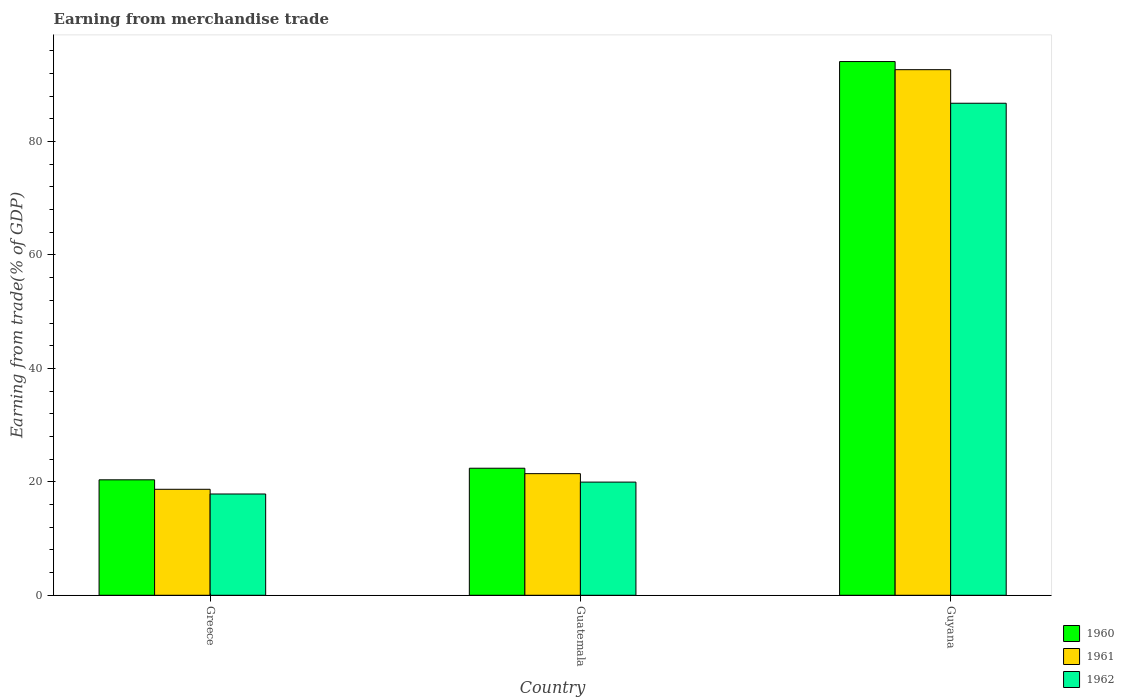Are the number of bars on each tick of the X-axis equal?
Offer a terse response. Yes. What is the label of the 2nd group of bars from the left?
Give a very brief answer. Guatemala. In how many cases, is the number of bars for a given country not equal to the number of legend labels?
Your answer should be compact. 0. What is the earnings from trade in 1961 in Greece?
Your answer should be compact. 18.69. Across all countries, what is the maximum earnings from trade in 1960?
Offer a terse response. 94.1. Across all countries, what is the minimum earnings from trade in 1962?
Your answer should be very brief. 17.86. In which country was the earnings from trade in 1962 maximum?
Your answer should be very brief. Guyana. In which country was the earnings from trade in 1960 minimum?
Offer a very short reply. Greece. What is the total earnings from trade in 1962 in the graph?
Ensure brevity in your answer.  124.57. What is the difference between the earnings from trade in 1961 in Greece and that in Guyana?
Provide a short and direct response. -73.98. What is the difference between the earnings from trade in 1962 in Guyana and the earnings from trade in 1961 in Greece?
Make the answer very short. 68.07. What is the average earnings from trade in 1961 per country?
Your answer should be very brief. 44.27. What is the difference between the earnings from trade of/in 1961 and earnings from trade of/in 1962 in Guyana?
Offer a terse response. 5.92. What is the ratio of the earnings from trade in 1962 in Greece to that in Guyana?
Your answer should be compact. 0.21. Is the earnings from trade in 1961 in Greece less than that in Guatemala?
Your response must be concise. Yes. Is the difference between the earnings from trade in 1961 in Greece and Guyana greater than the difference between the earnings from trade in 1962 in Greece and Guyana?
Offer a very short reply. No. What is the difference between the highest and the second highest earnings from trade in 1961?
Your answer should be very brief. -73.98. What is the difference between the highest and the lowest earnings from trade in 1960?
Your answer should be very brief. 73.74. In how many countries, is the earnings from trade in 1962 greater than the average earnings from trade in 1962 taken over all countries?
Your answer should be very brief. 1. What does the 3rd bar from the left in Guatemala represents?
Offer a terse response. 1962. What does the 1st bar from the right in Greece represents?
Ensure brevity in your answer.  1962. Is it the case that in every country, the sum of the earnings from trade in 1962 and earnings from trade in 1961 is greater than the earnings from trade in 1960?
Make the answer very short. Yes. Are all the bars in the graph horizontal?
Provide a short and direct response. No. How many countries are there in the graph?
Make the answer very short. 3. What is the difference between two consecutive major ticks on the Y-axis?
Keep it short and to the point. 20. Are the values on the major ticks of Y-axis written in scientific E-notation?
Give a very brief answer. No. Does the graph contain any zero values?
Provide a short and direct response. No. Does the graph contain grids?
Your response must be concise. No. How are the legend labels stacked?
Offer a terse response. Vertical. What is the title of the graph?
Provide a succinct answer. Earning from merchandise trade. Does "1984" appear as one of the legend labels in the graph?
Keep it short and to the point. No. What is the label or title of the X-axis?
Ensure brevity in your answer.  Country. What is the label or title of the Y-axis?
Your response must be concise. Earning from trade(% of GDP). What is the Earning from trade(% of GDP) in 1960 in Greece?
Make the answer very short. 20.36. What is the Earning from trade(% of GDP) in 1961 in Greece?
Ensure brevity in your answer.  18.69. What is the Earning from trade(% of GDP) of 1962 in Greece?
Your answer should be compact. 17.86. What is the Earning from trade(% of GDP) in 1960 in Guatemala?
Give a very brief answer. 22.4. What is the Earning from trade(% of GDP) in 1961 in Guatemala?
Give a very brief answer. 21.44. What is the Earning from trade(% of GDP) in 1962 in Guatemala?
Your response must be concise. 19.96. What is the Earning from trade(% of GDP) of 1960 in Guyana?
Offer a terse response. 94.1. What is the Earning from trade(% of GDP) of 1961 in Guyana?
Your answer should be compact. 92.67. What is the Earning from trade(% of GDP) in 1962 in Guyana?
Provide a succinct answer. 86.75. Across all countries, what is the maximum Earning from trade(% of GDP) in 1960?
Keep it short and to the point. 94.1. Across all countries, what is the maximum Earning from trade(% of GDP) of 1961?
Offer a terse response. 92.67. Across all countries, what is the maximum Earning from trade(% of GDP) of 1962?
Make the answer very short. 86.75. Across all countries, what is the minimum Earning from trade(% of GDP) in 1960?
Give a very brief answer. 20.36. Across all countries, what is the minimum Earning from trade(% of GDP) in 1961?
Ensure brevity in your answer.  18.69. Across all countries, what is the minimum Earning from trade(% of GDP) in 1962?
Your response must be concise. 17.86. What is the total Earning from trade(% of GDP) of 1960 in the graph?
Ensure brevity in your answer.  136.86. What is the total Earning from trade(% of GDP) in 1961 in the graph?
Your answer should be compact. 132.8. What is the total Earning from trade(% of GDP) in 1962 in the graph?
Provide a succinct answer. 124.57. What is the difference between the Earning from trade(% of GDP) in 1960 in Greece and that in Guatemala?
Offer a terse response. -2.04. What is the difference between the Earning from trade(% of GDP) in 1961 in Greece and that in Guatemala?
Offer a terse response. -2.76. What is the difference between the Earning from trade(% of GDP) in 1962 in Greece and that in Guatemala?
Keep it short and to the point. -2.1. What is the difference between the Earning from trade(% of GDP) of 1960 in Greece and that in Guyana?
Offer a very short reply. -73.74. What is the difference between the Earning from trade(% of GDP) of 1961 in Greece and that in Guyana?
Provide a short and direct response. -73.98. What is the difference between the Earning from trade(% of GDP) of 1962 in Greece and that in Guyana?
Provide a short and direct response. -68.9. What is the difference between the Earning from trade(% of GDP) of 1960 in Guatemala and that in Guyana?
Ensure brevity in your answer.  -71.7. What is the difference between the Earning from trade(% of GDP) in 1961 in Guatemala and that in Guyana?
Your response must be concise. -71.23. What is the difference between the Earning from trade(% of GDP) of 1962 in Guatemala and that in Guyana?
Ensure brevity in your answer.  -66.8. What is the difference between the Earning from trade(% of GDP) of 1960 in Greece and the Earning from trade(% of GDP) of 1961 in Guatemala?
Your response must be concise. -1.09. What is the difference between the Earning from trade(% of GDP) of 1960 in Greece and the Earning from trade(% of GDP) of 1962 in Guatemala?
Your answer should be compact. 0.4. What is the difference between the Earning from trade(% of GDP) of 1961 in Greece and the Earning from trade(% of GDP) of 1962 in Guatemala?
Your answer should be compact. -1.27. What is the difference between the Earning from trade(% of GDP) of 1960 in Greece and the Earning from trade(% of GDP) of 1961 in Guyana?
Provide a succinct answer. -72.31. What is the difference between the Earning from trade(% of GDP) of 1960 in Greece and the Earning from trade(% of GDP) of 1962 in Guyana?
Give a very brief answer. -66.4. What is the difference between the Earning from trade(% of GDP) of 1961 in Greece and the Earning from trade(% of GDP) of 1962 in Guyana?
Give a very brief answer. -68.07. What is the difference between the Earning from trade(% of GDP) in 1960 in Guatemala and the Earning from trade(% of GDP) in 1961 in Guyana?
Your answer should be very brief. -70.27. What is the difference between the Earning from trade(% of GDP) of 1960 in Guatemala and the Earning from trade(% of GDP) of 1962 in Guyana?
Provide a short and direct response. -64.35. What is the difference between the Earning from trade(% of GDP) in 1961 in Guatemala and the Earning from trade(% of GDP) in 1962 in Guyana?
Make the answer very short. -65.31. What is the average Earning from trade(% of GDP) in 1960 per country?
Make the answer very short. 45.62. What is the average Earning from trade(% of GDP) of 1961 per country?
Keep it short and to the point. 44.27. What is the average Earning from trade(% of GDP) of 1962 per country?
Your response must be concise. 41.52. What is the difference between the Earning from trade(% of GDP) of 1960 and Earning from trade(% of GDP) of 1961 in Greece?
Keep it short and to the point. 1.67. What is the difference between the Earning from trade(% of GDP) of 1960 and Earning from trade(% of GDP) of 1962 in Greece?
Offer a terse response. 2.5. What is the difference between the Earning from trade(% of GDP) in 1961 and Earning from trade(% of GDP) in 1962 in Greece?
Ensure brevity in your answer.  0.83. What is the difference between the Earning from trade(% of GDP) in 1960 and Earning from trade(% of GDP) in 1961 in Guatemala?
Give a very brief answer. 0.96. What is the difference between the Earning from trade(% of GDP) in 1960 and Earning from trade(% of GDP) in 1962 in Guatemala?
Provide a short and direct response. 2.44. What is the difference between the Earning from trade(% of GDP) of 1961 and Earning from trade(% of GDP) of 1962 in Guatemala?
Your answer should be compact. 1.49. What is the difference between the Earning from trade(% of GDP) of 1960 and Earning from trade(% of GDP) of 1961 in Guyana?
Your answer should be compact. 1.43. What is the difference between the Earning from trade(% of GDP) of 1960 and Earning from trade(% of GDP) of 1962 in Guyana?
Give a very brief answer. 7.35. What is the difference between the Earning from trade(% of GDP) of 1961 and Earning from trade(% of GDP) of 1962 in Guyana?
Offer a very short reply. 5.92. What is the ratio of the Earning from trade(% of GDP) of 1960 in Greece to that in Guatemala?
Give a very brief answer. 0.91. What is the ratio of the Earning from trade(% of GDP) in 1961 in Greece to that in Guatemala?
Offer a very short reply. 0.87. What is the ratio of the Earning from trade(% of GDP) in 1962 in Greece to that in Guatemala?
Make the answer very short. 0.89. What is the ratio of the Earning from trade(% of GDP) in 1960 in Greece to that in Guyana?
Keep it short and to the point. 0.22. What is the ratio of the Earning from trade(% of GDP) of 1961 in Greece to that in Guyana?
Offer a very short reply. 0.2. What is the ratio of the Earning from trade(% of GDP) in 1962 in Greece to that in Guyana?
Give a very brief answer. 0.21. What is the ratio of the Earning from trade(% of GDP) in 1960 in Guatemala to that in Guyana?
Your answer should be very brief. 0.24. What is the ratio of the Earning from trade(% of GDP) of 1961 in Guatemala to that in Guyana?
Your response must be concise. 0.23. What is the ratio of the Earning from trade(% of GDP) of 1962 in Guatemala to that in Guyana?
Ensure brevity in your answer.  0.23. What is the difference between the highest and the second highest Earning from trade(% of GDP) in 1960?
Your answer should be very brief. 71.7. What is the difference between the highest and the second highest Earning from trade(% of GDP) in 1961?
Offer a very short reply. 71.23. What is the difference between the highest and the second highest Earning from trade(% of GDP) of 1962?
Make the answer very short. 66.8. What is the difference between the highest and the lowest Earning from trade(% of GDP) of 1960?
Make the answer very short. 73.74. What is the difference between the highest and the lowest Earning from trade(% of GDP) in 1961?
Offer a terse response. 73.98. What is the difference between the highest and the lowest Earning from trade(% of GDP) of 1962?
Keep it short and to the point. 68.9. 